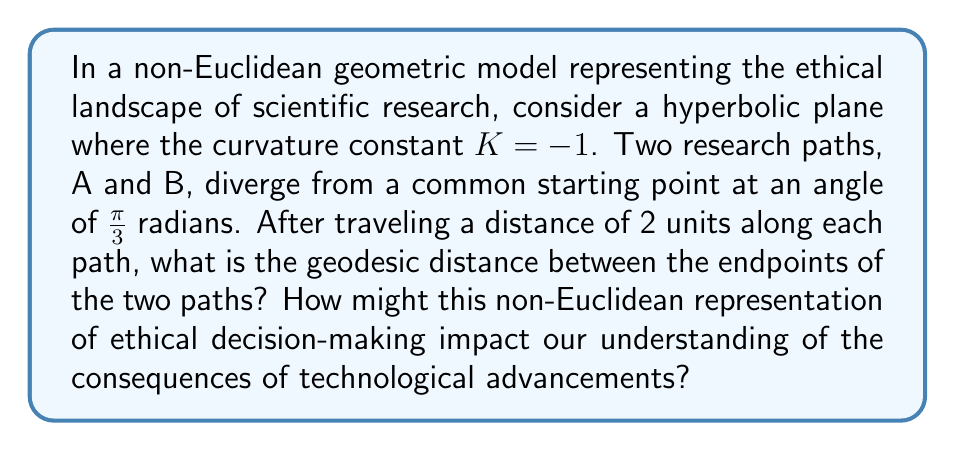What is the answer to this math problem? To solve this problem, we'll use the hyperbolic law of cosines and follow these steps:

1) In hyperbolic geometry, the law of cosines for a triangle with sides a, b, c and angle C opposite side c is:

   $$\cosh(c) = \cosh(a)\cosh(b) - \sinh(a)\sinh(b)\cos(C)$$

2) In our case:
   - a = b = 2 (the distance traveled along each path)
   - C = $\frac{\pi}{3}$ (the angle between the paths)
   - We need to find c (the geodesic distance between endpoints)

3) Let's substitute these values:

   $$\cosh(c) = \cosh(2)\cosh(2) - \sinh(2)\sinh(2)\cos(\frac{\pi}{3})$$

4) Calculate the hyperbolic functions:
   $$\cosh(2) \approx 3.7622$$
   $$\sinh(2) \approx 3.6269$$

5) Substitute these values:

   $$\cosh(c) = 3.7622 * 3.7622 - 3.6269 * 3.6269 * \cos(\frac{\pi}{3})$$

6) Simplify:
   $$\cosh(c) = 14.1541 - 13.1544 * 0.5 = 14.1541 - 6.5772 = 7.5769$$

7) To find c, we need to apply the inverse hyperbolic cosine:

   $$c = \text{arccosh}(7.5769) \approx 2.7845$$

This result demonstrates that in non-Euclidean space, the distance between endpoints is greater than it would be in Euclidean space, reflecting the complexity of ethical decision-making in scientific research. The curvature of the space represents how ethical considerations can cause seemingly parallel research paths to diverge more rapidly than expected.

This non-Euclidean representation impacts our understanding of technological advancements by illustrating that:

1) Ethical implications of research choices may have farther-reaching consequences than initially apparent.
2) The "distance" between different ethical outcomes may be larger than intuition suggests.
3) Traditional linear models of progress may not adequately capture the complexity of ethical decision-making in scientific advancement.
Answer: 2.7845 units; It illustrates greater ethical divergence and complexity in scientific decision-making than Euclidean models. 